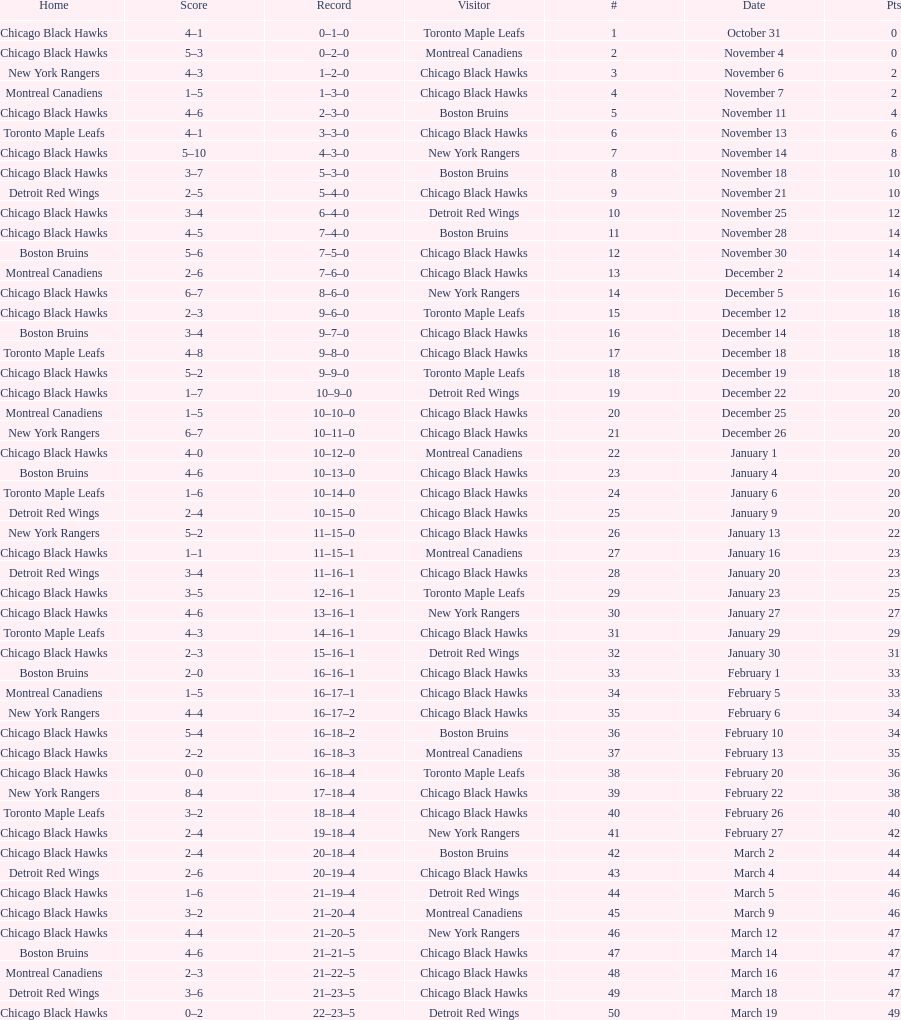How long is the duration of one season (from the first game to the last)? 5 months. 